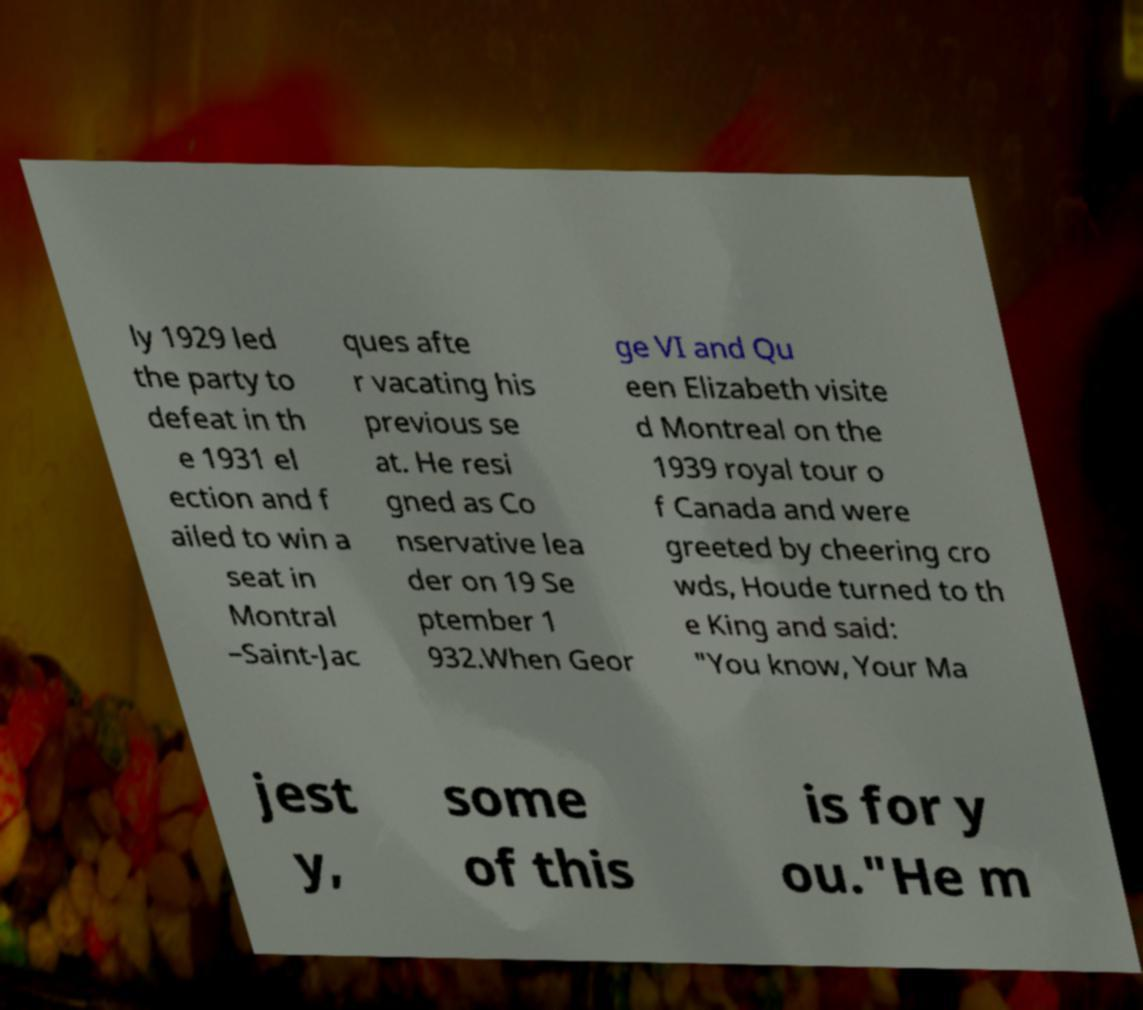Please read and relay the text visible in this image. What does it say? ly 1929 led the party to defeat in th e 1931 el ection and f ailed to win a seat in Montral –Saint-Jac ques afte r vacating his previous se at. He resi gned as Co nservative lea der on 19 Se ptember 1 932.When Geor ge VI and Qu een Elizabeth visite d Montreal on the 1939 royal tour o f Canada and were greeted by cheering cro wds, Houde turned to th e King and said: "You know, Your Ma jest y, some of this is for y ou."He m 